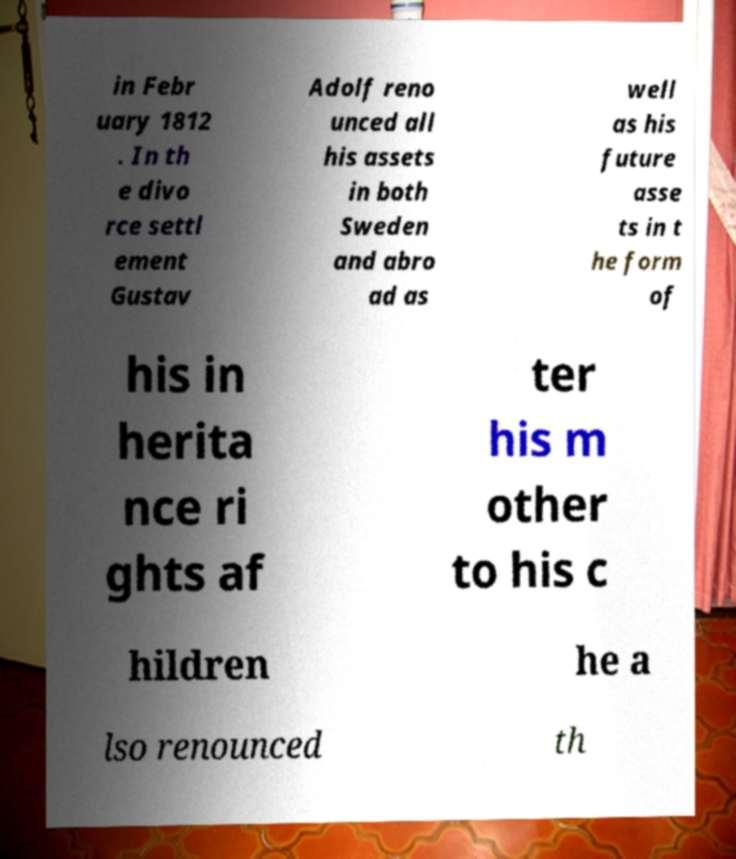Please identify and transcribe the text found in this image. in Febr uary 1812 . In th e divo rce settl ement Gustav Adolf reno unced all his assets in both Sweden and abro ad as well as his future asse ts in t he form of his in herita nce ri ghts af ter his m other to his c hildren he a lso renounced th 